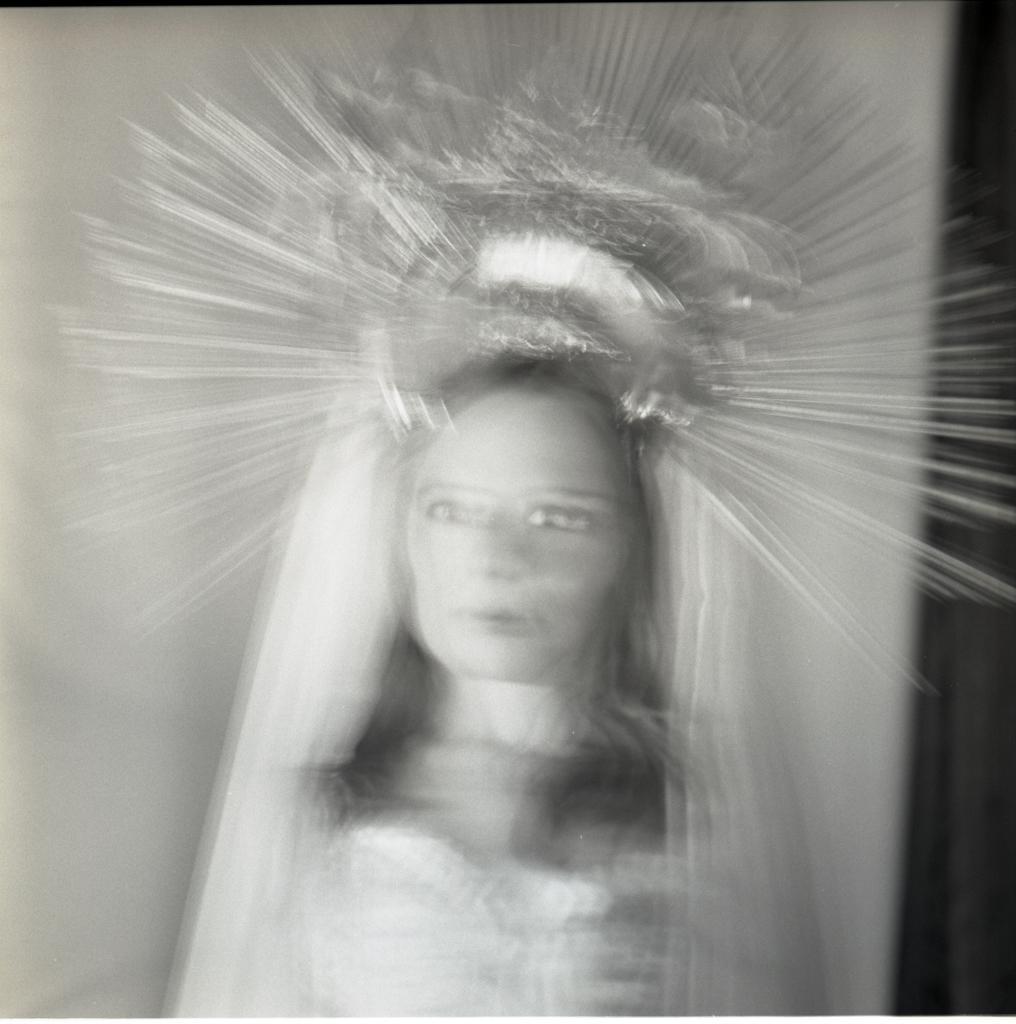Please provide a concise description of this image. In this black and white picture there is a woman. There is a crown on her head. The image is shaky. 